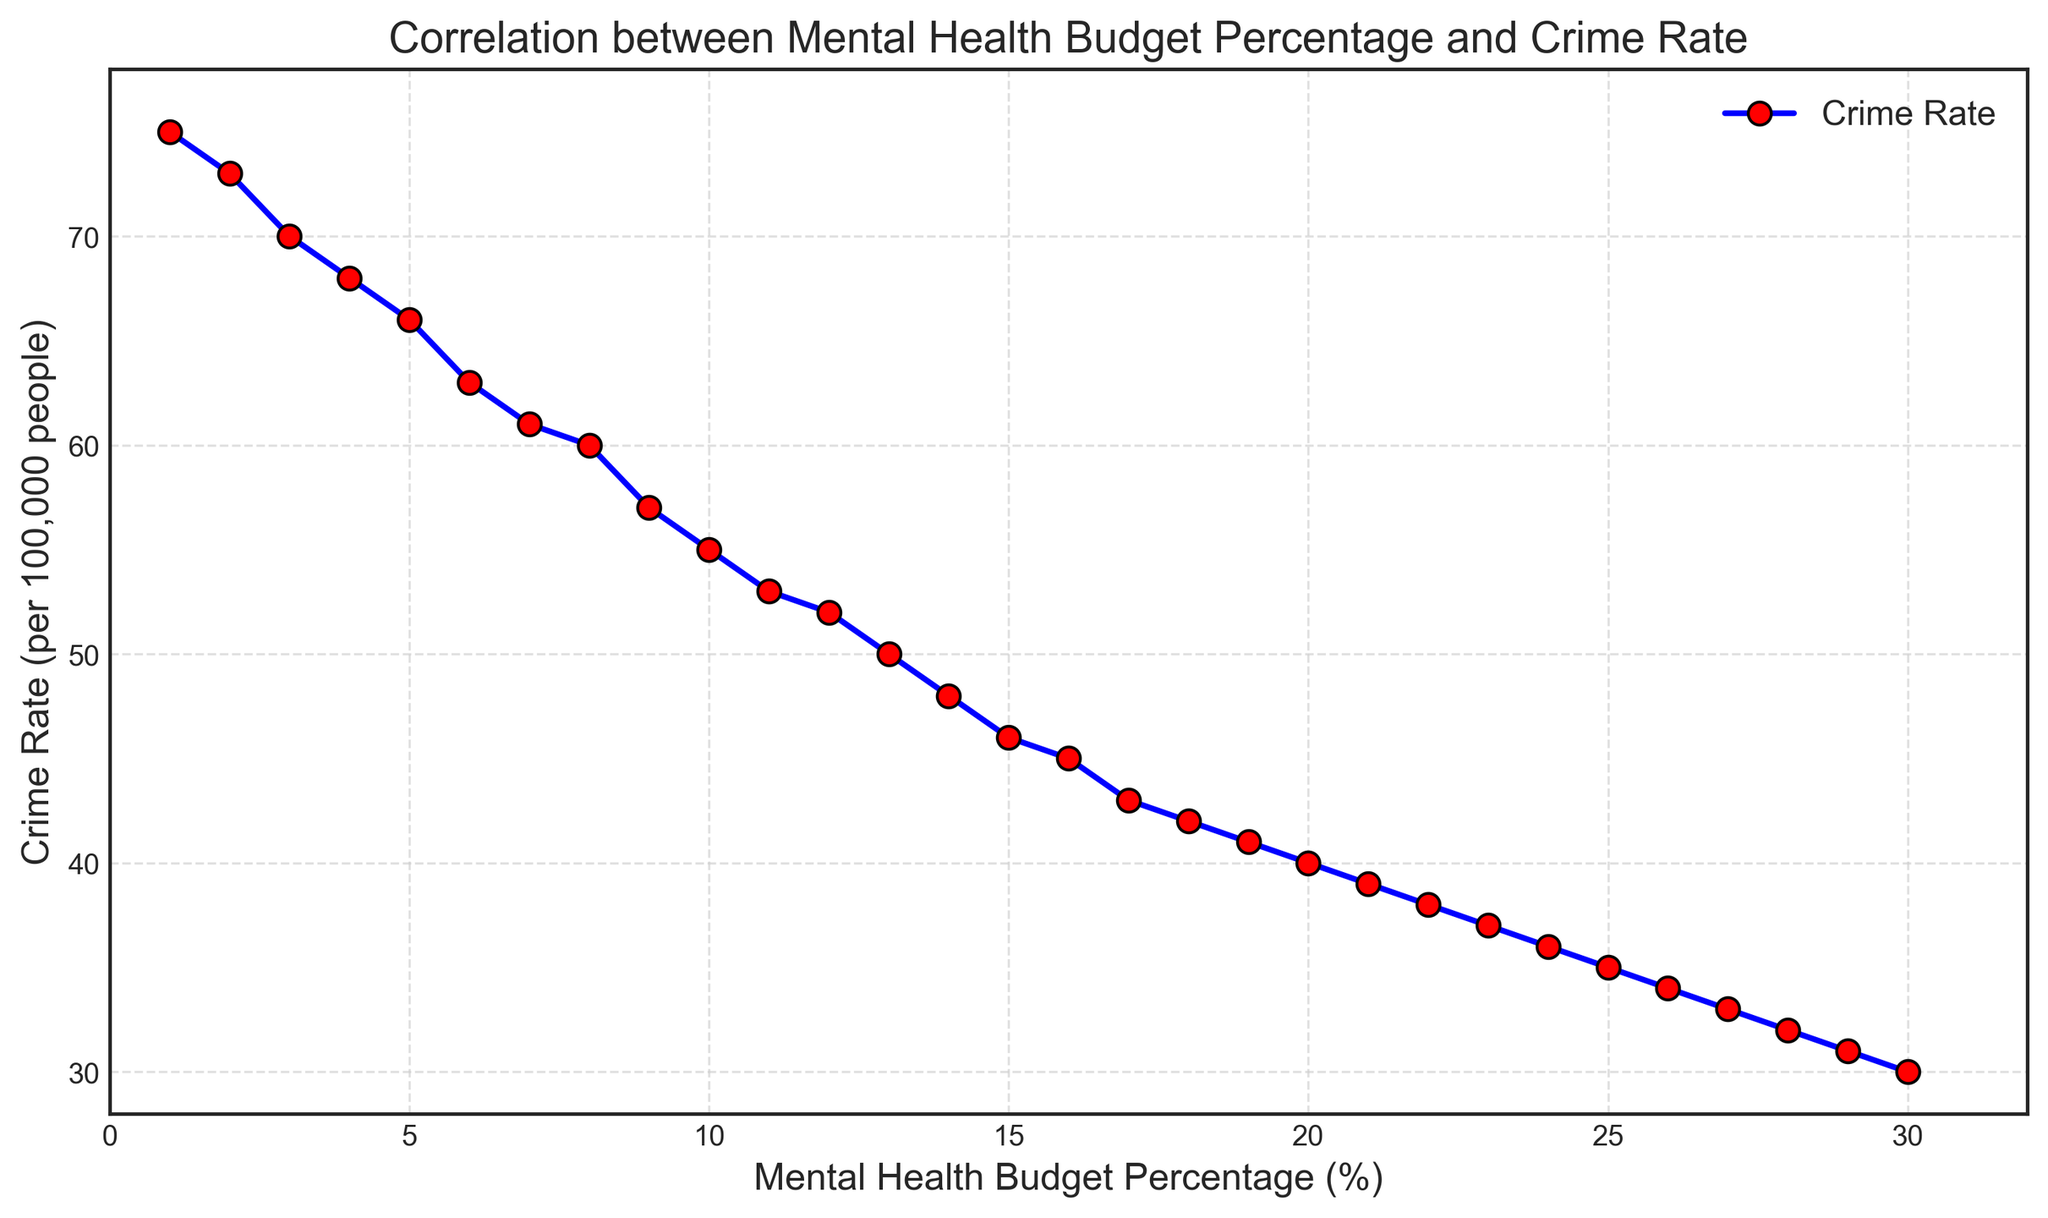What correlation is observed between the mental health budget percentage and the crime rate? The plot shows a downward trend, indicating that as the mental health budget percentage increases, the crime rate decreases.
Answer: Negative correlation When the mental health budget percentage is at 15%, what is the corresponding crime rate? According to the plot, find the point where the mental health budget is 15% and read the corresponding crime rate value from the y-axis.
Answer: 46 per 100,000 people By how much does the crime rate decrease when the mental health budget percentage increases from 5% to 10%? Look at the crime rates at 5% and 10%. The crime rate at 5% is 66, and at 10% it is 55. Subtract the latter from the former: 66 - 55.
Answer: 11 per 100,000 people If the mental health budget percentage is doubled from 10% to 20%, what is the decrease in crime rate? The crime rate at 10% is 55, and at 20% it is 40. Subtract the latter from the former: 55 - 40.
Answer: 15 per 100,000 people What is the overall trend of the crime rate from the lowest to the highest mental health budget percentage? Observing the plot, the trend shows that the crime rate consistently decreases as the mental health budget percentage increases.
Answer: Decreasing trend What is the difference in crime rate between the points where the mental health budget percentage is 8% and 25%? The crime rate at 8% is 60, and at 25% it is 35. Subtract the latter from the former: 60 - 35.
Answer: 25 per 100,000 people Between the mental health budget percentages of 12% and 18%, what interval has the highest rate of crime reduction? Calculate the crime rate decrease for each interval: 12% to 15% (52 to 46) is 6, and 15% to 18% (46 to 42) is 4. The highest reduction is in the interval 12% to 15%.
Answer: 12% to 15% Do you see any outliers in the trend of crime rate reduction as the mental health budget increases? Based on the plot, observe if any data points significantly deviate from the overall trend. All points follow a smooth, decreasing line without outliers.
Answer: No How does the crime rate change at each step of increasing the mental health budget by 1%? The plot shows a relatively linear decrease, meaning each 1% increase in the mental health budget roughly results in a reduction of about 1-2 per 100,000 people in crime rate.
Answer: Decreases by about 1-2 per 100,000 people What are the extreme values of the crime rate observed in the plot, and at what mental health budget percentages do they occur? The highest crime rate is 75 at 1% budget and the lowest is 30 at 30% budget.
Answer: 75 at 1%, 30 at 30% 